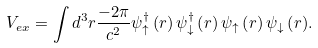Convert formula to latex. <formula><loc_0><loc_0><loc_500><loc_500>V _ { e x } = \int { d ^ { 3 } r \frac { - 2 \pi } { c ^ { 2 } } \psi _ { \uparrow } ^ { \dag } \left ( r \right ) \psi _ { \downarrow } ^ { \dag } \left ( r \right ) \psi _ { \uparrow } \left ( r \right ) \psi _ { \downarrow } \left ( r \right ) } .</formula> 